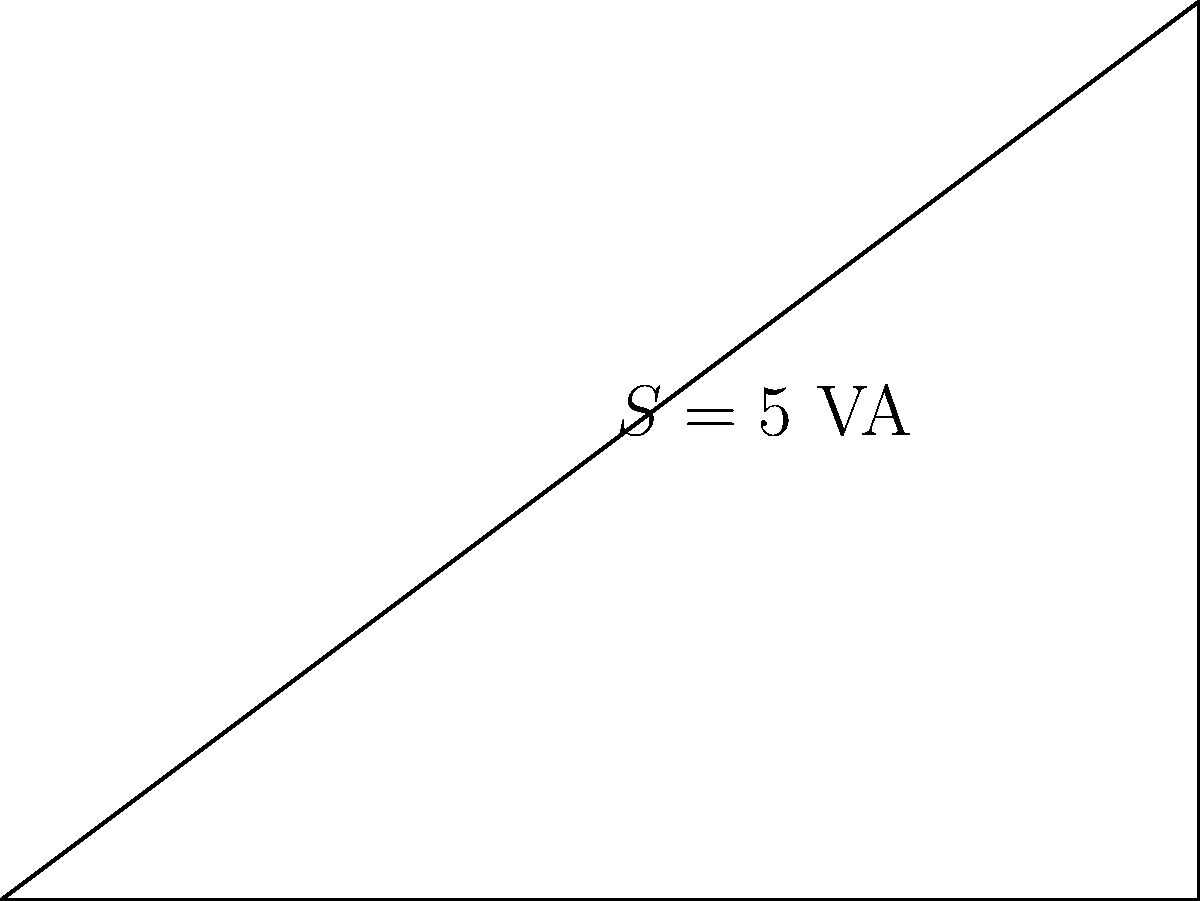In the power triangle shown above, what is the power factor of this electrical system? To find the power factor, we need to follow these steps:

1. Recall that power factor (PF) is defined as the ratio of real power to apparent power:

   $PF = \frac{P}{S}$

2. From the power triangle, we can see:
   - Real power (P) = 4 W
   - Apparent power (S) = 5 VA

3. Substituting these values into the power factor formula:

   $PF = \frac{4 \text{ W}}{5 \text{ VA}} = 0.8$

4. Alternatively, we can calculate the power factor as the cosine of the angle $\theta$:

   $PF = \cos(\theta) = \frac{P}{S} = \frac{4}{5} = 0.8$

5. Both methods yield the same result: a power factor of 0.8.

Note: The power factor is always a dimensionless quantity between 0 and 1.
Answer: 0.8 